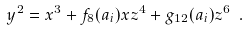<formula> <loc_0><loc_0><loc_500><loc_500>y ^ { 2 } = x ^ { 3 } + f _ { 8 } ( a _ { i } ) x z ^ { 4 } + g _ { 1 2 } ( a _ { i } ) z ^ { 6 } \ .</formula> 